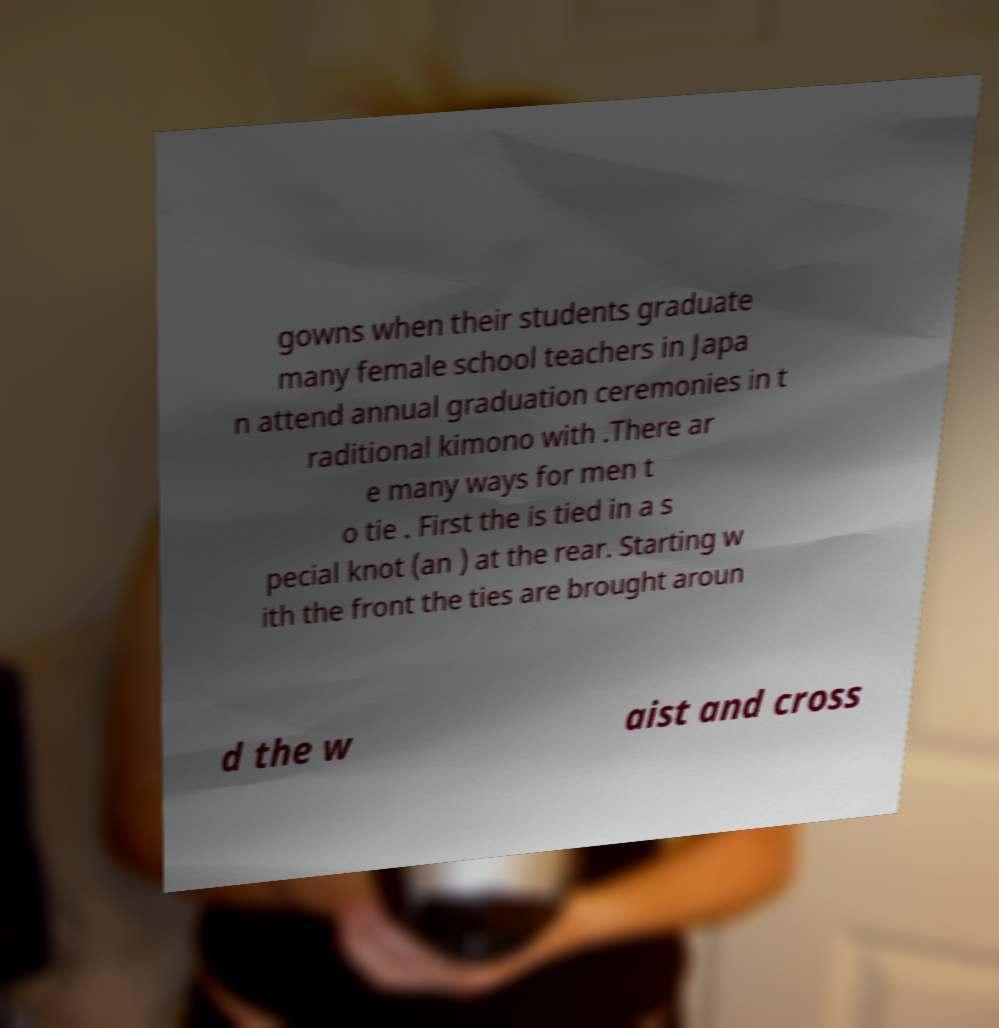Please identify and transcribe the text found in this image. gowns when their students graduate many female school teachers in Japa n attend annual graduation ceremonies in t raditional kimono with .There ar e many ways for men t o tie . First the is tied in a s pecial knot (an ) at the rear. Starting w ith the front the ties are brought aroun d the w aist and cross 